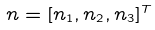Convert formula to latex. <formula><loc_0><loc_0><loc_500><loc_500>n = [ n _ { 1 } , n _ { 2 } , n _ { 3 } ] ^ { T }</formula> 